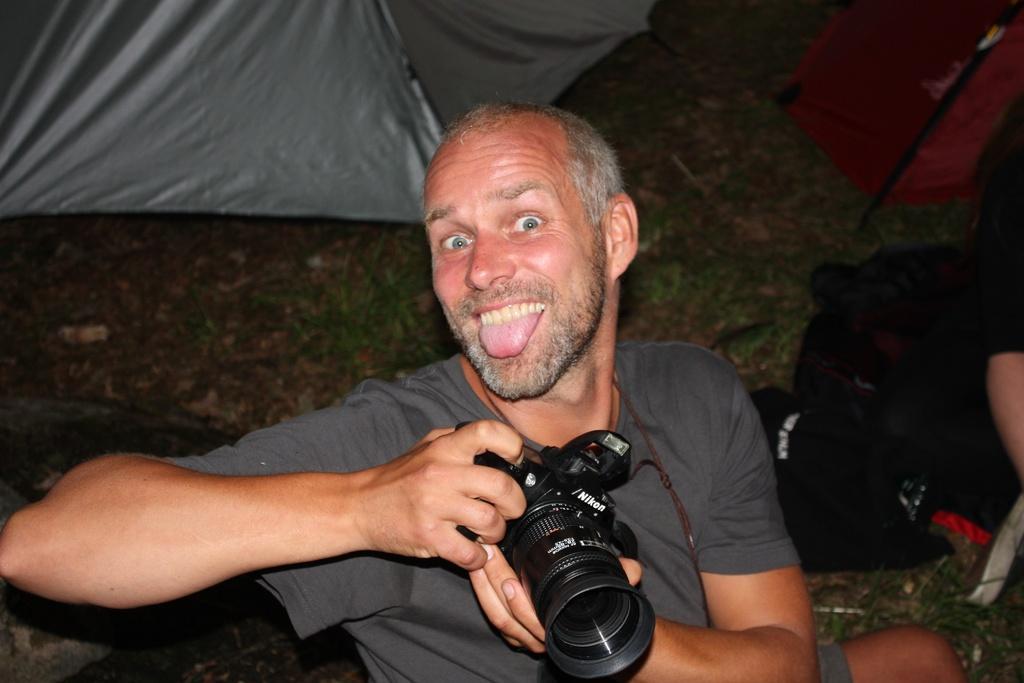In one or two sentences, can you explain what this image depicts? In this image the man is holding a camera. 